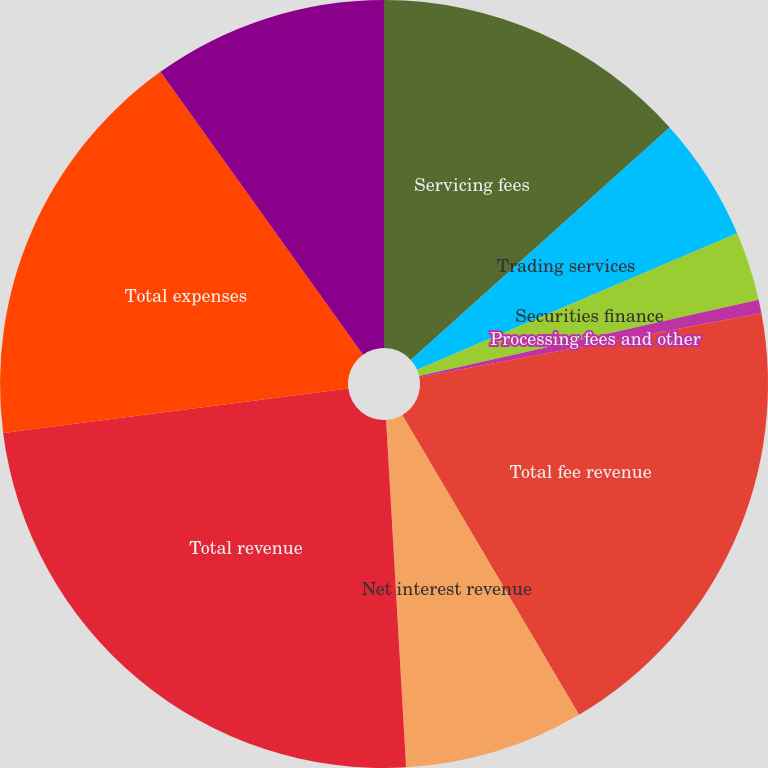Convert chart. <chart><loc_0><loc_0><loc_500><loc_500><pie_chart><fcel>Servicing fees<fcel>Trading services<fcel>Securities finance<fcel>Processing fees and other<fcel>Total fee revenue<fcel>Net interest revenue<fcel>Total revenue<fcel>Total expenses<fcel>Income before income tax<nl><fcel>13.35%<fcel>5.23%<fcel>2.9%<fcel>0.57%<fcel>19.47%<fcel>7.56%<fcel>23.88%<fcel>17.14%<fcel>9.89%<nl></chart> 